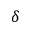<formula> <loc_0><loc_0><loc_500><loc_500>\delta</formula> 